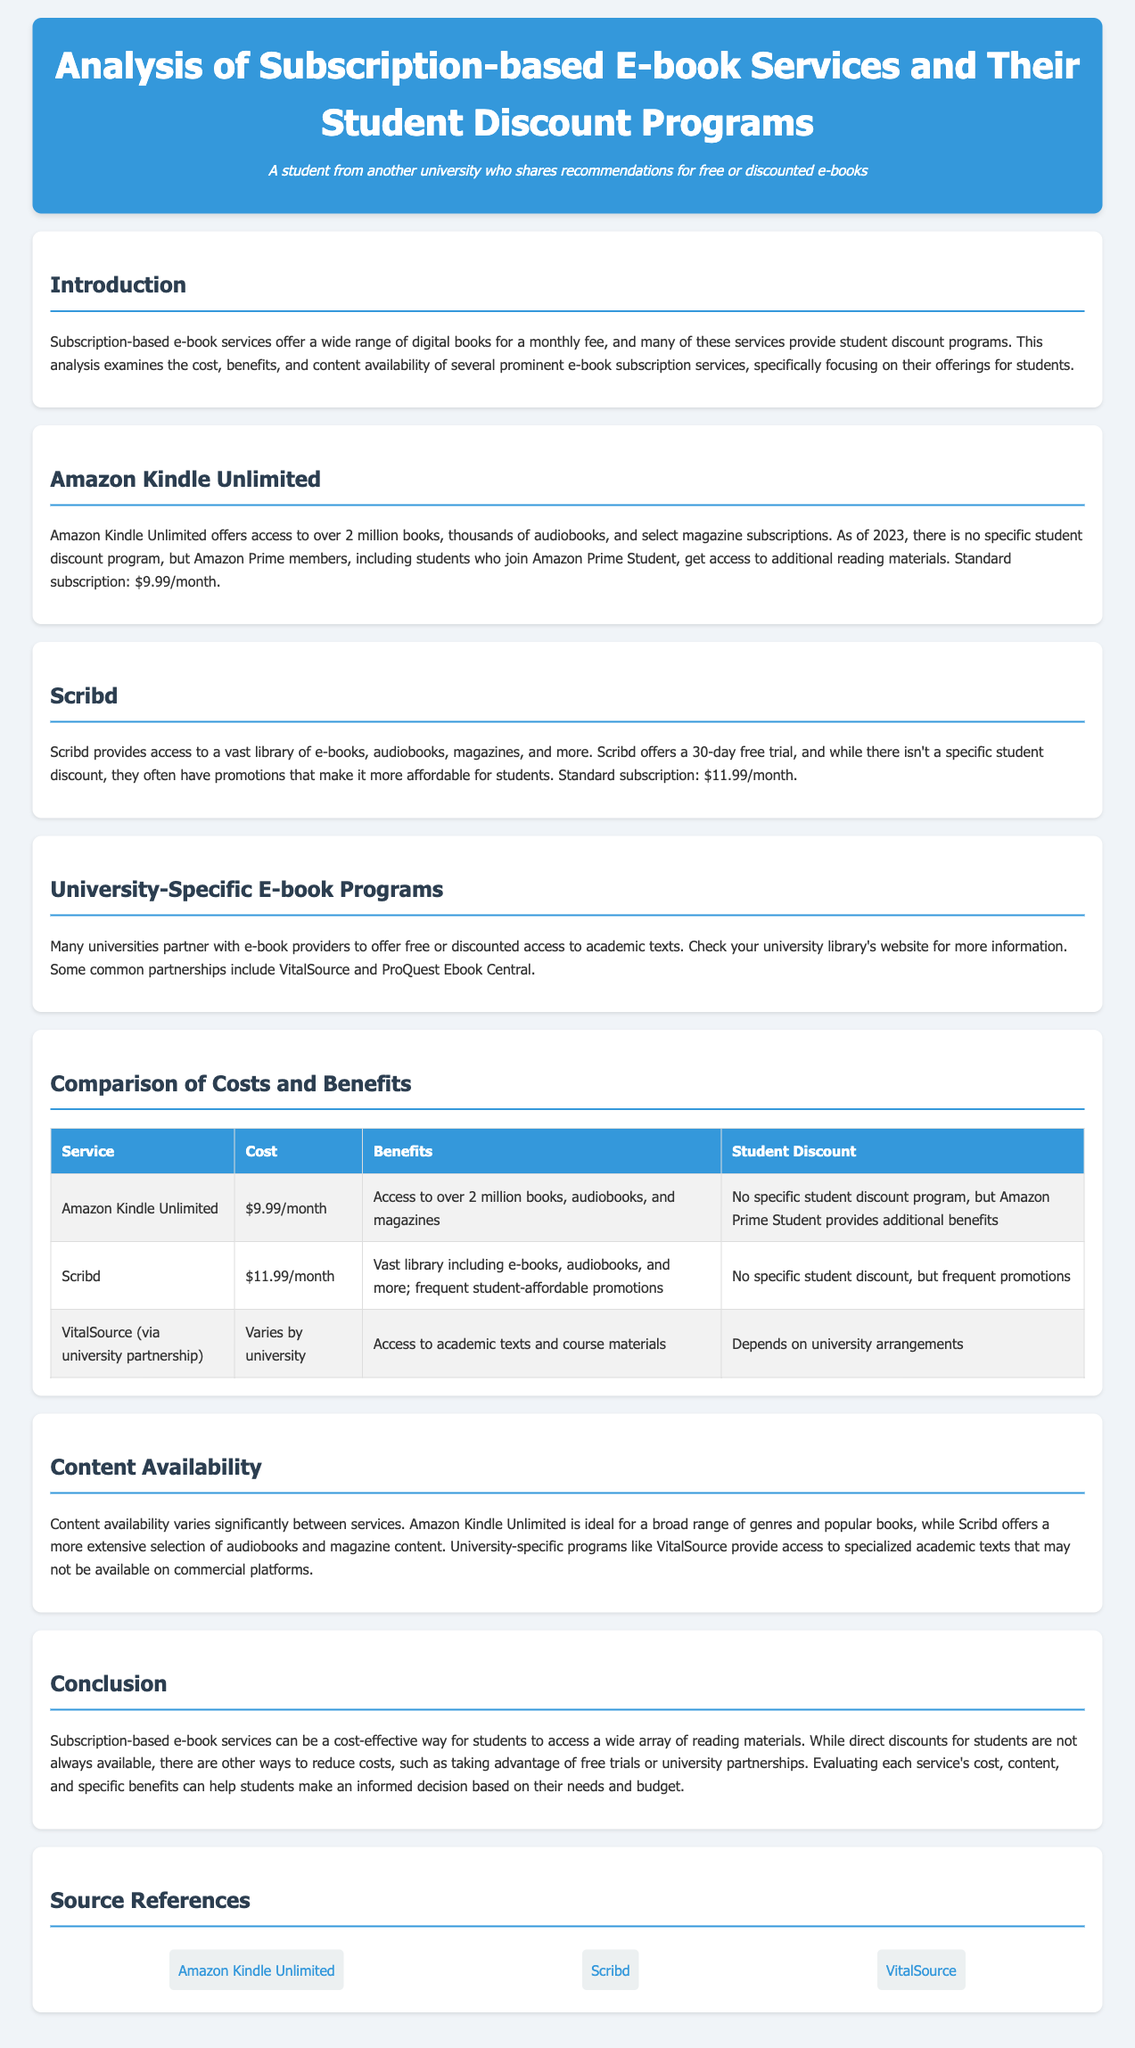What is the standard subscription cost for Amazon Kindle Unlimited? The standard subscription for Amazon Kindle Unlimited is mentioned in the document as $9.99 per month.
Answer: $9.99/month What types of content does Scribd provide access to? The document states that Scribd provides access to e-books, audiobooks, magazines, and more.
Answer: e-books, audiobooks, magazines Is there a specific student discount program for Scribd? The document indicates that there isn't a specific student discount for Scribd, but there are often promotions.
Answer: No What is the access type offered by VitalSource through university partnerships? The document states that VitalSource provides access to academic texts and course materials for students.
Answer: Academic texts and course materials Which service provides access to over 2 million books? The document explicitly mentions that Amazon Kindle Unlimited offers access to over 2 million books.
Answer: Amazon Kindle Unlimited What was the main focus of this analysis? The key focus of the analysis as stated in the introduction is on costs, benefits, and content availability of e-book subscription services for students.
Answer: Costs, benefits, and content availability According to the document, what is a way students can reduce costs on e-book services? The document suggests that students can reduce costs by taking advantage of free trials or university partnerships.
Answer: Free trials or university partnerships Which e-book service has a standard subscription cost of $11.99/month? Scribd is the service mentioned in the document with a standard subscription cost of $11.99 per month.
Answer: Scribd 